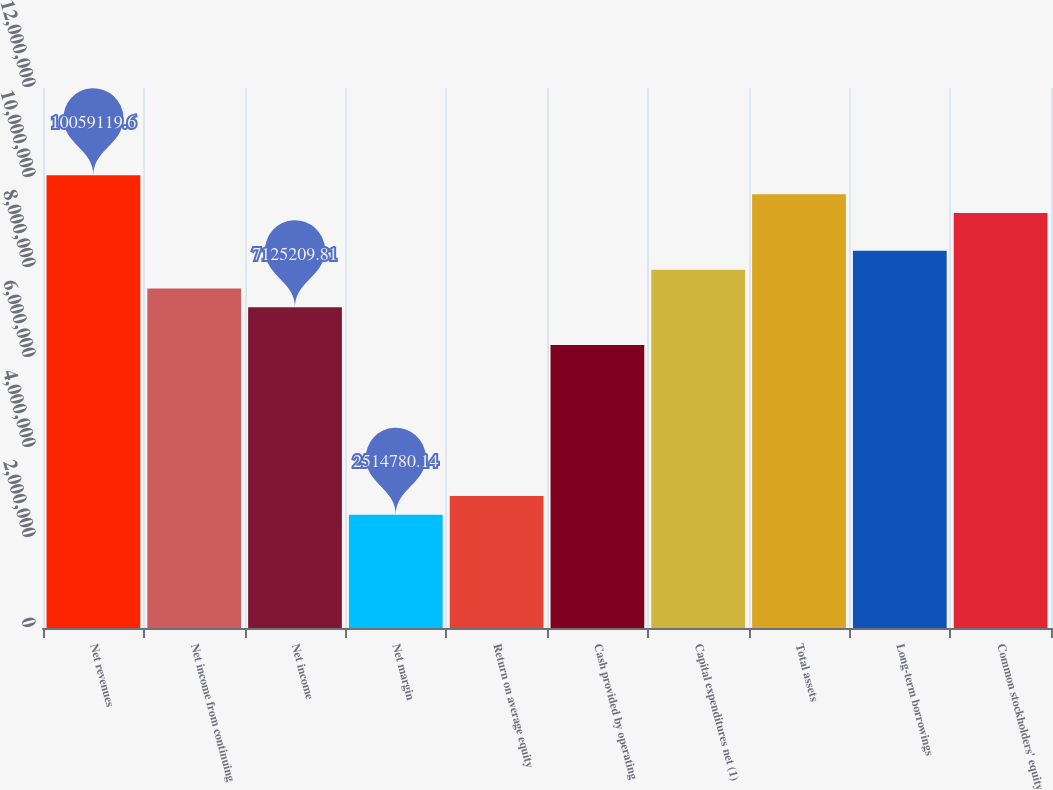Convert chart to OTSL. <chart><loc_0><loc_0><loc_500><loc_500><bar_chart><fcel>Net revenues<fcel>Net income from continuing<fcel>Net income<fcel>Net margin<fcel>Return on average equity<fcel>Cash provided by operating<fcel>Capital expenditures net (1)<fcel>Total assets<fcel>Long-term borrowings<fcel>Common stockholders' equity<nl><fcel>1.00591e+07<fcel>7.54434e+06<fcel>7.12521e+06<fcel>2.51478e+06<fcel>2.93391e+06<fcel>6.28695e+06<fcel>7.96347e+06<fcel>9.63999e+06<fcel>8.3826e+06<fcel>9.22086e+06<nl></chart> 